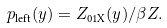<formula> <loc_0><loc_0><loc_500><loc_500>p _ { \text {left} } ( y ) = Z _ { \text {01X} } ( y ) / \beta Z .</formula> 